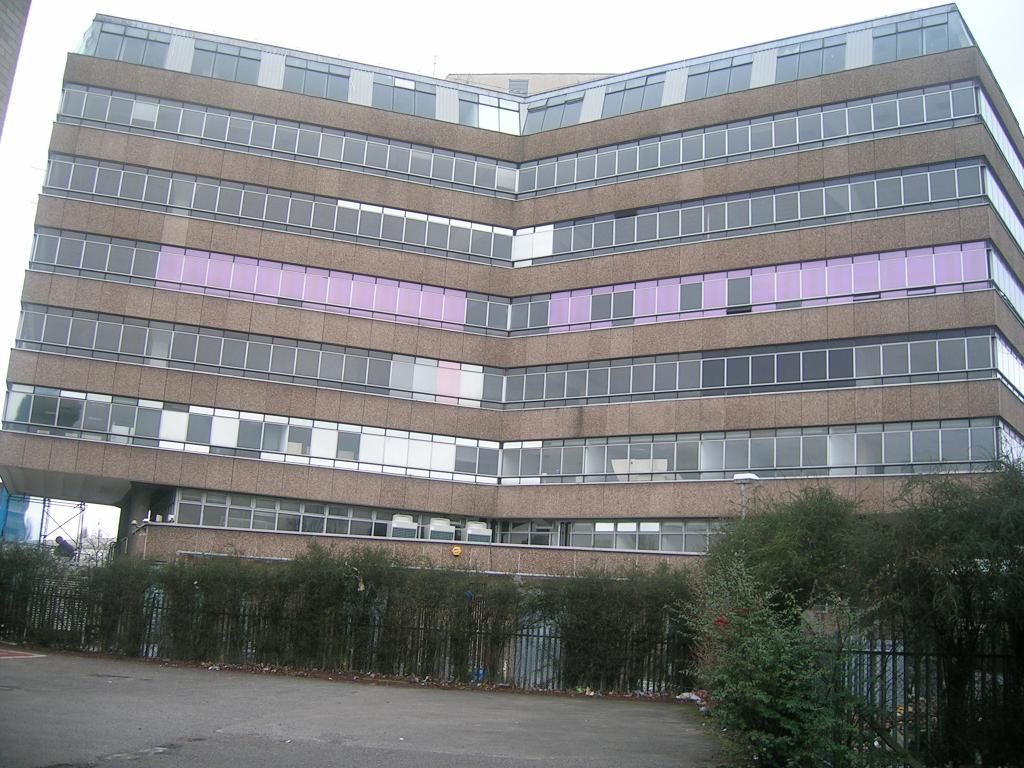What type of structure is present in the image? There is a building in the picture. What is located near the building? There is a fence in the picture. What type of vegetation can be seen in the image? There are plants in the picture. What can be seen in the background of the image? The sky is visible in the background of the picture. What thoughts does the father have about the battle in the image? There is no father or battle present in the image, so it is not possible to answer that question. 